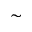<formula> <loc_0><loc_0><loc_500><loc_500>\sim</formula> 